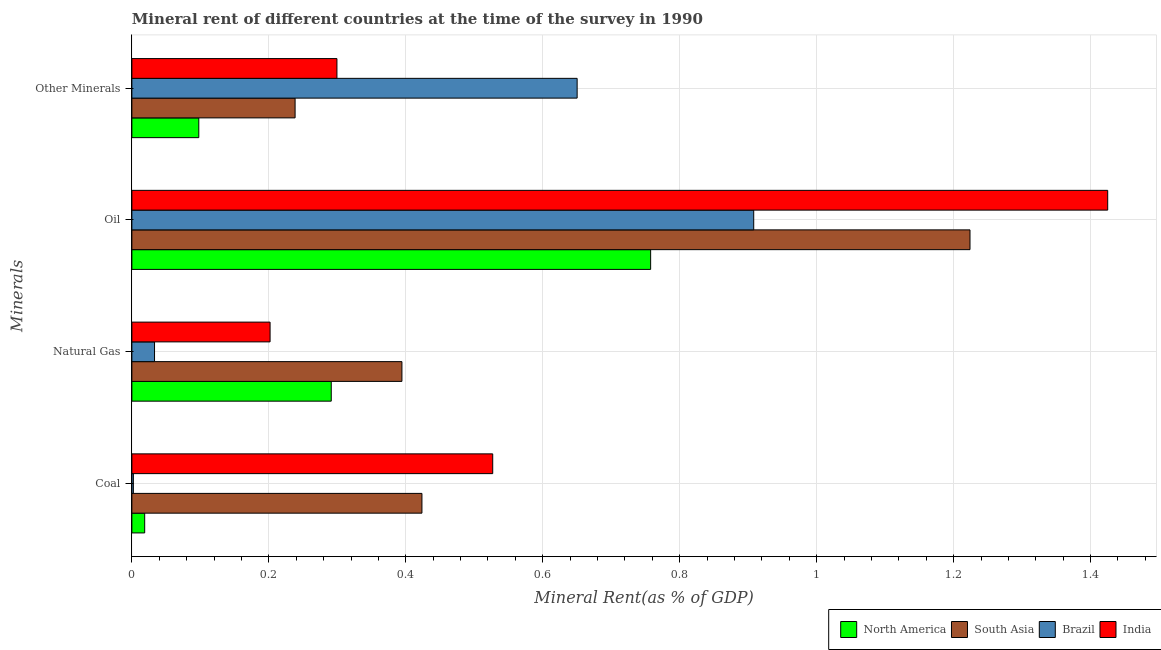How many different coloured bars are there?
Make the answer very short. 4. How many groups of bars are there?
Provide a short and direct response. 4. Are the number of bars per tick equal to the number of legend labels?
Make the answer very short. Yes. How many bars are there on the 1st tick from the top?
Ensure brevity in your answer.  4. What is the label of the 1st group of bars from the top?
Your answer should be very brief. Other Minerals. What is the coal rent in North America?
Provide a succinct answer. 0.02. Across all countries, what is the maximum coal rent?
Offer a very short reply. 0.53. Across all countries, what is the minimum oil rent?
Your answer should be very brief. 0.76. In which country was the oil rent minimum?
Provide a succinct answer. North America. What is the total  rent of other minerals in the graph?
Your answer should be compact. 1.29. What is the difference between the coal rent in India and that in South Asia?
Keep it short and to the point. 0.1. What is the difference between the natural gas rent in South Asia and the oil rent in Brazil?
Provide a short and direct response. -0.51. What is the average oil rent per country?
Provide a short and direct response. 1.08. What is the difference between the  rent of other minerals and oil rent in South Asia?
Ensure brevity in your answer.  -0.99. What is the ratio of the  rent of other minerals in Brazil to that in South Asia?
Provide a short and direct response. 2.73. Is the natural gas rent in India less than that in North America?
Ensure brevity in your answer.  Yes. What is the difference between the highest and the second highest oil rent?
Give a very brief answer. 0.2. What is the difference between the highest and the lowest oil rent?
Provide a succinct answer. 0.67. Is it the case that in every country, the sum of the oil rent and natural gas rent is greater than the sum of  rent of other minerals and coal rent?
Offer a very short reply. Yes. Is it the case that in every country, the sum of the coal rent and natural gas rent is greater than the oil rent?
Your answer should be compact. No. Are all the bars in the graph horizontal?
Your answer should be very brief. Yes. What is the difference between two consecutive major ticks on the X-axis?
Your response must be concise. 0.2. Are the values on the major ticks of X-axis written in scientific E-notation?
Ensure brevity in your answer.  No. Where does the legend appear in the graph?
Offer a very short reply. Bottom right. How are the legend labels stacked?
Provide a succinct answer. Horizontal. What is the title of the graph?
Your answer should be very brief. Mineral rent of different countries at the time of the survey in 1990. What is the label or title of the X-axis?
Ensure brevity in your answer.  Mineral Rent(as % of GDP). What is the label or title of the Y-axis?
Your response must be concise. Minerals. What is the Mineral Rent(as % of GDP) of North America in Coal?
Provide a succinct answer. 0.02. What is the Mineral Rent(as % of GDP) of South Asia in Coal?
Make the answer very short. 0.42. What is the Mineral Rent(as % of GDP) of Brazil in Coal?
Your answer should be very brief. 0. What is the Mineral Rent(as % of GDP) of India in Coal?
Ensure brevity in your answer.  0.53. What is the Mineral Rent(as % of GDP) in North America in Natural Gas?
Offer a terse response. 0.29. What is the Mineral Rent(as % of GDP) of South Asia in Natural Gas?
Ensure brevity in your answer.  0.39. What is the Mineral Rent(as % of GDP) in Brazil in Natural Gas?
Ensure brevity in your answer.  0.03. What is the Mineral Rent(as % of GDP) of India in Natural Gas?
Provide a succinct answer. 0.2. What is the Mineral Rent(as % of GDP) in North America in Oil?
Give a very brief answer. 0.76. What is the Mineral Rent(as % of GDP) in South Asia in Oil?
Offer a terse response. 1.22. What is the Mineral Rent(as % of GDP) in Brazil in Oil?
Ensure brevity in your answer.  0.91. What is the Mineral Rent(as % of GDP) of India in Oil?
Give a very brief answer. 1.42. What is the Mineral Rent(as % of GDP) of North America in Other Minerals?
Provide a short and direct response. 0.1. What is the Mineral Rent(as % of GDP) in South Asia in Other Minerals?
Your answer should be very brief. 0.24. What is the Mineral Rent(as % of GDP) in Brazil in Other Minerals?
Your answer should be compact. 0.65. What is the Mineral Rent(as % of GDP) of India in Other Minerals?
Give a very brief answer. 0.3. Across all Minerals, what is the maximum Mineral Rent(as % of GDP) of North America?
Your response must be concise. 0.76. Across all Minerals, what is the maximum Mineral Rent(as % of GDP) in South Asia?
Ensure brevity in your answer.  1.22. Across all Minerals, what is the maximum Mineral Rent(as % of GDP) of Brazil?
Offer a very short reply. 0.91. Across all Minerals, what is the maximum Mineral Rent(as % of GDP) in India?
Make the answer very short. 1.42. Across all Minerals, what is the minimum Mineral Rent(as % of GDP) of North America?
Your answer should be very brief. 0.02. Across all Minerals, what is the minimum Mineral Rent(as % of GDP) in South Asia?
Provide a short and direct response. 0.24. Across all Minerals, what is the minimum Mineral Rent(as % of GDP) in Brazil?
Give a very brief answer. 0. Across all Minerals, what is the minimum Mineral Rent(as % of GDP) of India?
Give a very brief answer. 0.2. What is the total Mineral Rent(as % of GDP) of North America in the graph?
Your response must be concise. 1.17. What is the total Mineral Rent(as % of GDP) in South Asia in the graph?
Ensure brevity in your answer.  2.28. What is the total Mineral Rent(as % of GDP) in Brazil in the graph?
Ensure brevity in your answer.  1.59. What is the total Mineral Rent(as % of GDP) of India in the graph?
Your response must be concise. 2.45. What is the difference between the Mineral Rent(as % of GDP) in North America in Coal and that in Natural Gas?
Your response must be concise. -0.27. What is the difference between the Mineral Rent(as % of GDP) of South Asia in Coal and that in Natural Gas?
Make the answer very short. 0.03. What is the difference between the Mineral Rent(as % of GDP) of Brazil in Coal and that in Natural Gas?
Your response must be concise. -0.03. What is the difference between the Mineral Rent(as % of GDP) of India in Coal and that in Natural Gas?
Offer a very short reply. 0.33. What is the difference between the Mineral Rent(as % of GDP) of North America in Coal and that in Oil?
Give a very brief answer. -0.74. What is the difference between the Mineral Rent(as % of GDP) in South Asia in Coal and that in Oil?
Make the answer very short. -0.8. What is the difference between the Mineral Rent(as % of GDP) of Brazil in Coal and that in Oil?
Your answer should be very brief. -0.91. What is the difference between the Mineral Rent(as % of GDP) in India in Coal and that in Oil?
Offer a very short reply. -0.9. What is the difference between the Mineral Rent(as % of GDP) of North America in Coal and that in Other Minerals?
Your answer should be very brief. -0.08. What is the difference between the Mineral Rent(as % of GDP) in South Asia in Coal and that in Other Minerals?
Keep it short and to the point. 0.19. What is the difference between the Mineral Rent(as % of GDP) in Brazil in Coal and that in Other Minerals?
Offer a very short reply. -0.65. What is the difference between the Mineral Rent(as % of GDP) of India in Coal and that in Other Minerals?
Ensure brevity in your answer.  0.23. What is the difference between the Mineral Rent(as % of GDP) in North America in Natural Gas and that in Oil?
Keep it short and to the point. -0.47. What is the difference between the Mineral Rent(as % of GDP) in South Asia in Natural Gas and that in Oil?
Offer a terse response. -0.83. What is the difference between the Mineral Rent(as % of GDP) in Brazil in Natural Gas and that in Oil?
Your response must be concise. -0.88. What is the difference between the Mineral Rent(as % of GDP) of India in Natural Gas and that in Oil?
Your answer should be very brief. -1.22. What is the difference between the Mineral Rent(as % of GDP) in North America in Natural Gas and that in Other Minerals?
Your response must be concise. 0.19. What is the difference between the Mineral Rent(as % of GDP) in South Asia in Natural Gas and that in Other Minerals?
Make the answer very short. 0.16. What is the difference between the Mineral Rent(as % of GDP) in Brazil in Natural Gas and that in Other Minerals?
Make the answer very short. -0.62. What is the difference between the Mineral Rent(as % of GDP) of India in Natural Gas and that in Other Minerals?
Offer a terse response. -0.1. What is the difference between the Mineral Rent(as % of GDP) of North America in Oil and that in Other Minerals?
Offer a terse response. 0.66. What is the difference between the Mineral Rent(as % of GDP) in South Asia in Oil and that in Other Minerals?
Ensure brevity in your answer.  0.99. What is the difference between the Mineral Rent(as % of GDP) in Brazil in Oil and that in Other Minerals?
Provide a succinct answer. 0.26. What is the difference between the Mineral Rent(as % of GDP) of India in Oil and that in Other Minerals?
Ensure brevity in your answer.  1.13. What is the difference between the Mineral Rent(as % of GDP) in North America in Coal and the Mineral Rent(as % of GDP) in South Asia in Natural Gas?
Give a very brief answer. -0.38. What is the difference between the Mineral Rent(as % of GDP) of North America in Coal and the Mineral Rent(as % of GDP) of Brazil in Natural Gas?
Keep it short and to the point. -0.01. What is the difference between the Mineral Rent(as % of GDP) of North America in Coal and the Mineral Rent(as % of GDP) of India in Natural Gas?
Provide a succinct answer. -0.18. What is the difference between the Mineral Rent(as % of GDP) of South Asia in Coal and the Mineral Rent(as % of GDP) of Brazil in Natural Gas?
Keep it short and to the point. 0.39. What is the difference between the Mineral Rent(as % of GDP) in South Asia in Coal and the Mineral Rent(as % of GDP) in India in Natural Gas?
Your response must be concise. 0.22. What is the difference between the Mineral Rent(as % of GDP) of Brazil in Coal and the Mineral Rent(as % of GDP) of India in Natural Gas?
Your answer should be very brief. -0.2. What is the difference between the Mineral Rent(as % of GDP) of North America in Coal and the Mineral Rent(as % of GDP) of South Asia in Oil?
Provide a short and direct response. -1.21. What is the difference between the Mineral Rent(as % of GDP) in North America in Coal and the Mineral Rent(as % of GDP) in Brazil in Oil?
Provide a short and direct response. -0.89. What is the difference between the Mineral Rent(as % of GDP) of North America in Coal and the Mineral Rent(as % of GDP) of India in Oil?
Give a very brief answer. -1.41. What is the difference between the Mineral Rent(as % of GDP) of South Asia in Coal and the Mineral Rent(as % of GDP) of Brazil in Oil?
Keep it short and to the point. -0.48. What is the difference between the Mineral Rent(as % of GDP) of South Asia in Coal and the Mineral Rent(as % of GDP) of India in Oil?
Give a very brief answer. -1. What is the difference between the Mineral Rent(as % of GDP) of Brazil in Coal and the Mineral Rent(as % of GDP) of India in Oil?
Offer a terse response. -1.42. What is the difference between the Mineral Rent(as % of GDP) in North America in Coal and the Mineral Rent(as % of GDP) in South Asia in Other Minerals?
Keep it short and to the point. -0.22. What is the difference between the Mineral Rent(as % of GDP) in North America in Coal and the Mineral Rent(as % of GDP) in Brazil in Other Minerals?
Your answer should be compact. -0.63. What is the difference between the Mineral Rent(as % of GDP) of North America in Coal and the Mineral Rent(as % of GDP) of India in Other Minerals?
Ensure brevity in your answer.  -0.28. What is the difference between the Mineral Rent(as % of GDP) in South Asia in Coal and the Mineral Rent(as % of GDP) in Brazil in Other Minerals?
Your answer should be compact. -0.23. What is the difference between the Mineral Rent(as % of GDP) of South Asia in Coal and the Mineral Rent(as % of GDP) of India in Other Minerals?
Provide a succinct answer. 0.12. What is the difference between the Mineral Rent(as % of GDP) of Brazil in Coal and the Mineral Rent(as % of GDP) of India in Other Minerals?
Provide a short and direct response. -0.3. What is the difference between the Mineral Rent(as % of GDP) of North America in Natural Gas and the Mineral Rent(as % of GDP) of South Asia in Oil?
Your response must be concise. -0.93. What is the difference between the Mineral Rent(as % of GDP) of North America in Natural Gas and the Mineral Rent(as % of GDP) of Brazil in Oil?
Give a very brief answer. -0.62. What is the difference between the Mineral Rent(as % of GDP) in North America in Natural Gas and the Mineral Rent(as % of GDP) in India in Oil?
Your answer should be compact. -1.13. What is the difference between the Mineral Rent(as % of GDP) in South Asia in Natural Gas and the Mineral Rent(as % of GDP) in Brazil in Oil?
Your response must be concise. -0.51. What is the difference between the Mineral Rent(as % of GDP) of South Asia in Natural Gas and the Mineral Rent(as % of GDP) of India in Oil?
Provide a short and direct response. -1.03. What is the difference between the Mineral Rent(as % of GDP) in Brazil in Natural Gas and the Mineral Rent(as % of GDP) in India in Oil?
Your answer should be compact. -1.39. What is the difference between the Mineral Rent(as % of GDP) of North America in Natural Gas and the Mineral Rent(as % of GDP) of South Asia in Other Minerals?
Your answer should be very brief. 0.05. What is the difference between the Mineral Rent(as % of GDP) in North America in Natural Gas and the Mineral Rent(as % of GDP) in Brazil in Other Minerals?
Offer a terse response. -0.36. What is the difference between the Mineral Rent(as % of GDP) in North America in Natural Gas and the Mineral Rent(as % of GDP) in India in Other Minerals?
Keep it short and to the point. -0.01. What is the difference between the Mineral Rent(as % of GDP) in South Asia in Natural Gas and the Mineral Rent(as % of GDP) in Brazil in Other Minerals?
Your response must be concise. -0.26. What is the difference between the Mineral Rent(as % of GDP) in South Asia in Natural Gas and the Mineral Rent(as % of GDP) in India in Other Minerals?
Your answer should be compact. 0.09. What is the difference between the Mineral Rent(as % of GDP) of Brazil in Natural Gas and the Mineral Rent(as % of GDP) of India in Other Minerals?
Give a very brief answer. -0.27. What is the difference between the Mineral Rent(as % of GDP) of North America in Oil and the Mineral Rent(as % of GDP) of South Asia in Other Minerals?
Make the answer very short. 0.52. What is the difference between the Mineral Rent(as % of GDP) of North America in Oil and the Mineral Rent(as % of GDP) of Brazil in Other Minerals?
Offer a terse response. 0.11. What is the difference between the Mineral Rent(as % of GDP) in North America in Oil and the Mineral Rent(as % of GDP) in India in Other Minerals?
Offer a terse response. 0.46. What is the difference between the Mineral Rent(as % of GDP) in South Asia in Oil and the Mineral Rent(as % of GDP) in Brazil in Other Minerals?
Give a very brief answer. 0.57. What is the difference between the Mineral Rent(as % of GDP) of South Asia in Oil and the Mineral Rent(as % of GDP) of India in Other Minerals?
Make the answer very short. 0.92. What is the difference between the Mineral Rent(as % of GDP) in Brazil in Oil and the Mineral Rent(as % of GDP) in India in Other Minerals?
Make the answer very short. 0.61. What is the average Mineral Rent(as % of GDP) in North America per Minerals?
Make the answer very short. 0.29. What is the average Mineral Rent(as % of GDP) of South Asia per Minerals?
Make the answer very short. 0.57. What is the average Mineral Rent(as % of GDP) in Brazil per Minerals?
Keep it short and to the point. 0.4. What is the average Mineral Rent(as % of GDP) of India per Minerals?
Offer a very short reply. 0.61. What is the difference between the Mineral Rent(as % of GDP) in North America and Mineral Rent(as % of GDP) in South Asia in Coal?
Provide a succinct answer. -0.4. What is the difference between the Mineral Rent(as % of GDP) in North America and Mineral Rent(as % of GDP) in Brazil in Coal?
Offer a very short reply. 0.02. What is the difference between the Mineral Rent(as % of GDP) of North America and Mineral Rent(as % of GDP) of India in Coal?
Your response must be concise. -0.51. What is the difference between the Mineral Rent(as % of GDP) of South Asia and Mineral Rent(as % of GDP) of Brazil in Coal?
Ensure brevity in your answer.  0.42. What is the difference between the Mineral Rent(as % of GDP) of South Asia and Mineral Rent(as % of GDP) of India in Coal?
Provide a succinct answer. -0.1. What is the difference between the Mineral Rent(as % of GDP) in Brazil and Mineral Rent(as % of GDP) in India in Coal?
Make the answer very short. -0.52. What is the difference between the Mineral Rent(as % of GDP) in North America and Mineral Rent(as % of GDP) in South Asia in Natural Gas?
Make the answer very short. -0.1. What is the difference between the Mineral Rent(as % of GDP) of North America and Mineral Rent(as % of GDP) of Brazil in Natural Gas?
Offer a terse response. 0.26. What is the difference between the Mineral Rent(as % of GDP) of North America and Mineral Rent(as % of GDP) of India in Natural Gas?
Your answer should be very brief. 0.09. What is the difference between the Mineral Rent(as % of GDP) in South Asia and Mineral Rent(as % of GDP) in Brazil in Natural Gas?
Provide a short and direct response. 0.36. What is the difference between the Mineral Rent(as % of GDP) of South Asia and Mineral Rent(as % of GDP) of India in Natural Gas?
Offer a very short reply. 0.19. What is the difference between the Mineral Rent(as % of GDP) of Brazil and Mineral Rent(as % of GDP) of India in Natural Gas?
Offer a terse response. -0.17. What is the difference between the Mineral Rent(as % of GDP) of North America and Mineral Rent(as % of GDP) of South Asia in Oil?
Ensure brevity in your answer.  -0.47. What is the difference between the Mineral Rent(as % of GDP) of North America and Mineral Rent(as % of GDP) of Brazil in Oil?
Keep it short and to the point. -0.15. What is the difference between the Mineral Rent(as % of GDP) of North America and Mineral Rent(as % of GDP) of India in Oil?
Your response must be concise. -0.67. What is the difference between the Mineral Rent(as % of GDP) in South Asia and Mineral Rent(as % of GDP) in Brazil in Oil?
Make the answer very short. 0.32. What is the difference between the Mineral Rent(as % of GDP) of South Asia and Mineral Rent(as % of GDP) of India in Oil?
Give a very brief answer. -0.2. What is the difference between the Mineral Rent(as % of GDP) in Brazil and Mineral Rent(as % of GDP) in India in Oil?
Give a very brief answer. -0.52. What is the difference between the Mineral Rent(as % of GDP) of North America and Mineral Rent(as % of GDP) of South Asia in Other Minerals?
Offer a very short reply. -0.14. What is the difference between the Mineral Rent(as % of GDP) in North America and Mineral Rent(as % of GDP) in Brazil in Other Minerals?
Your answer should be compact. -0.55. What is the difference between the Mineral Rent(as % of GDP) in North America and Mineral Rent(as % of GDP) in India in Other Minerals?
Your answer should be very brief. -0.2. What is the difference between the Mineral Rent(as % of GDP) of South Asia and Mineral Rent(as % of GDP) of Brazil in Other Minerals?
Offer a terse response. -0.41. What is the difference between the Mineral Rent(as % of GDP) in South Asia and Mineral Rent(as % of GDP) in India in Other Minerals?
Make the answer very short. -0.06. What is the difference between the Mineral Rent(as % of GDP) in Brazil and Mineral Rent(as % of GDP) in India in Other Minerals?
Offer a very short reply. 0.35. What is the ratio of the Mineral Rent(as % of GDP) in North America in Coal to that in Natural Gas?
Provide a short and direct response. 0.06. What is the ratio of the Mineral Rent(as % of GDP) in South Asia in Coal to that in Natural Gas?
Offer a terse response. 1.07. What is the ratio of the Mineral Rent(as % of GDP) in Brazil in Coal to that in Natural Gas?
Your response must be concise. 0.07. What is the ratio of the Mineral Rent(as % of GDP) of India in Coal to that in Natural Gas?
Offer a very short reply. 2.61. What is the ratio of the Mineral Rent(as % of GDP) of North America in Coal to that in Oil?
Provide a succinct answer. 0.02. What is the ratio of the Mineral Rent(as % of GDP) in South Asia in Coal to that in Oil?
Offer a very short reply. 0.35. What is the ratio of the Mineral Rent(as % of GDP) of Brazil in Coal to that in Oil?
Provide a short and direct response. 0. What is the ratio of the Mineral Rent(as % of GDP) in India in Coal to that in Oil?
Keep it short and to the point. 0.37. What is the ratio of the Mineral Rent(as % of GDP) of North America in Coal to that in Other Minerals?
Make the answer very short. 0.19. What is the ratio of the Mineral Rent(as % of GDP) of South Asia in Coal to that in Other Minerals?
Keep it short and to the point. 1.78. What is the ratio of the Mineral Rent(as % of GDP) in Brazil in Coal to that in Other Minerals?
Your answer should be compact. 0. What is the ratio of the Mineral Rent(as % of GDP) of India in Coal to that in Other Minerals?
Give a very brief answer. 1.76. What is the ratio of the Mineral Rent(as % of GDP) in North America in Natural Gas to that in Oil?
Offer a terse response. 0.38. What is the ratio of the Mineral Rent(as % of GDP) in South Asia in Natural Gas to that in Oil?
Make the answer very short. 0.32. What is the ratio of the Mineral Rent(as % of GDP) in Brazil in Natural Gas to that in Oil?
Make the answer very short. 0.04. What is the ratio of the Mineral Rent(as % of GDP) in India in Natural Gas to that in Oil?
Provide a short and direct response. 0.14. What is the ratio of the Mineral Rent(as % of GDP) in North America in Natural Gas to that in Other Minerals?
Make the answer very short. 2.98. What is the ratio of the Mineral Rent(as % of GDP) in South Asia in Natural Gas to that in Other Minerals?
Offer a very short reply. 1.65. What is the ratio of the Mineral Rent(as % of GDP) of Brazil in Natural Gas to that in Other Minerals?
Keep it short and to the point. 0.05. What is the ratio of the Mineral Rent(as % of GDP) of India in Natural Gas to that in Other Minerals?
Provide a short and direct response. 0.67. What is the ratio of the Mineral Rent(as % of GDP) of North America in Oil to that in Other Minerals?
Give a very brief answer. 7.75. What is the ratio of the Mineral Rent(as % of GDP) in South Asia in Oil to that in Other Minerals?
Provide a short and direct response. 5.13. What is the ratio of the Mineral Rent(as % of GDP) in Brazil in Oil to that in Other Minerals?
Your response must be concise. 1.4. What is the ratio of the Mineral Rent(as % of GDP) in India in Oil to that in Other Minerals?
Make the answer very short. 4.76. What is the difference between the highest and the second highest Mineral Rent(as % of GDP) in North America?
Provide a short and direct response. 0.47. What is the difference between the highest and the second highest Mineral Rent(as % of GDP) of South Asia?
Provide a short and direct response. 0.8. What is the difference between the highest and the second highest Mineral Rent(as % of GDP) in Brazil?
Provide a short and direct response. 0.26. What is the difference between the highest and the second highest Mineral Rent(as % of GDP) in India?
Offer a terse response. 0.9. What is the difference between the highest and the lowest Mineral Rent(as % of GDP) in North America?
Ensure brevity in your answer.  0.74. What is the difference between the highest and the lowest Mineral Rent(as % of GDP) of South Asia?
Offer a very short reply. 0.99. What is the difference between the highest and the lowest Mineral Rent(as % of GDP) in Brazil?
Make the answer very short. 0.91. What is the difference between the highest and the lowest Mineral Rent(as % of GDP) of India?
Your answer should be very brief. 1.22. 